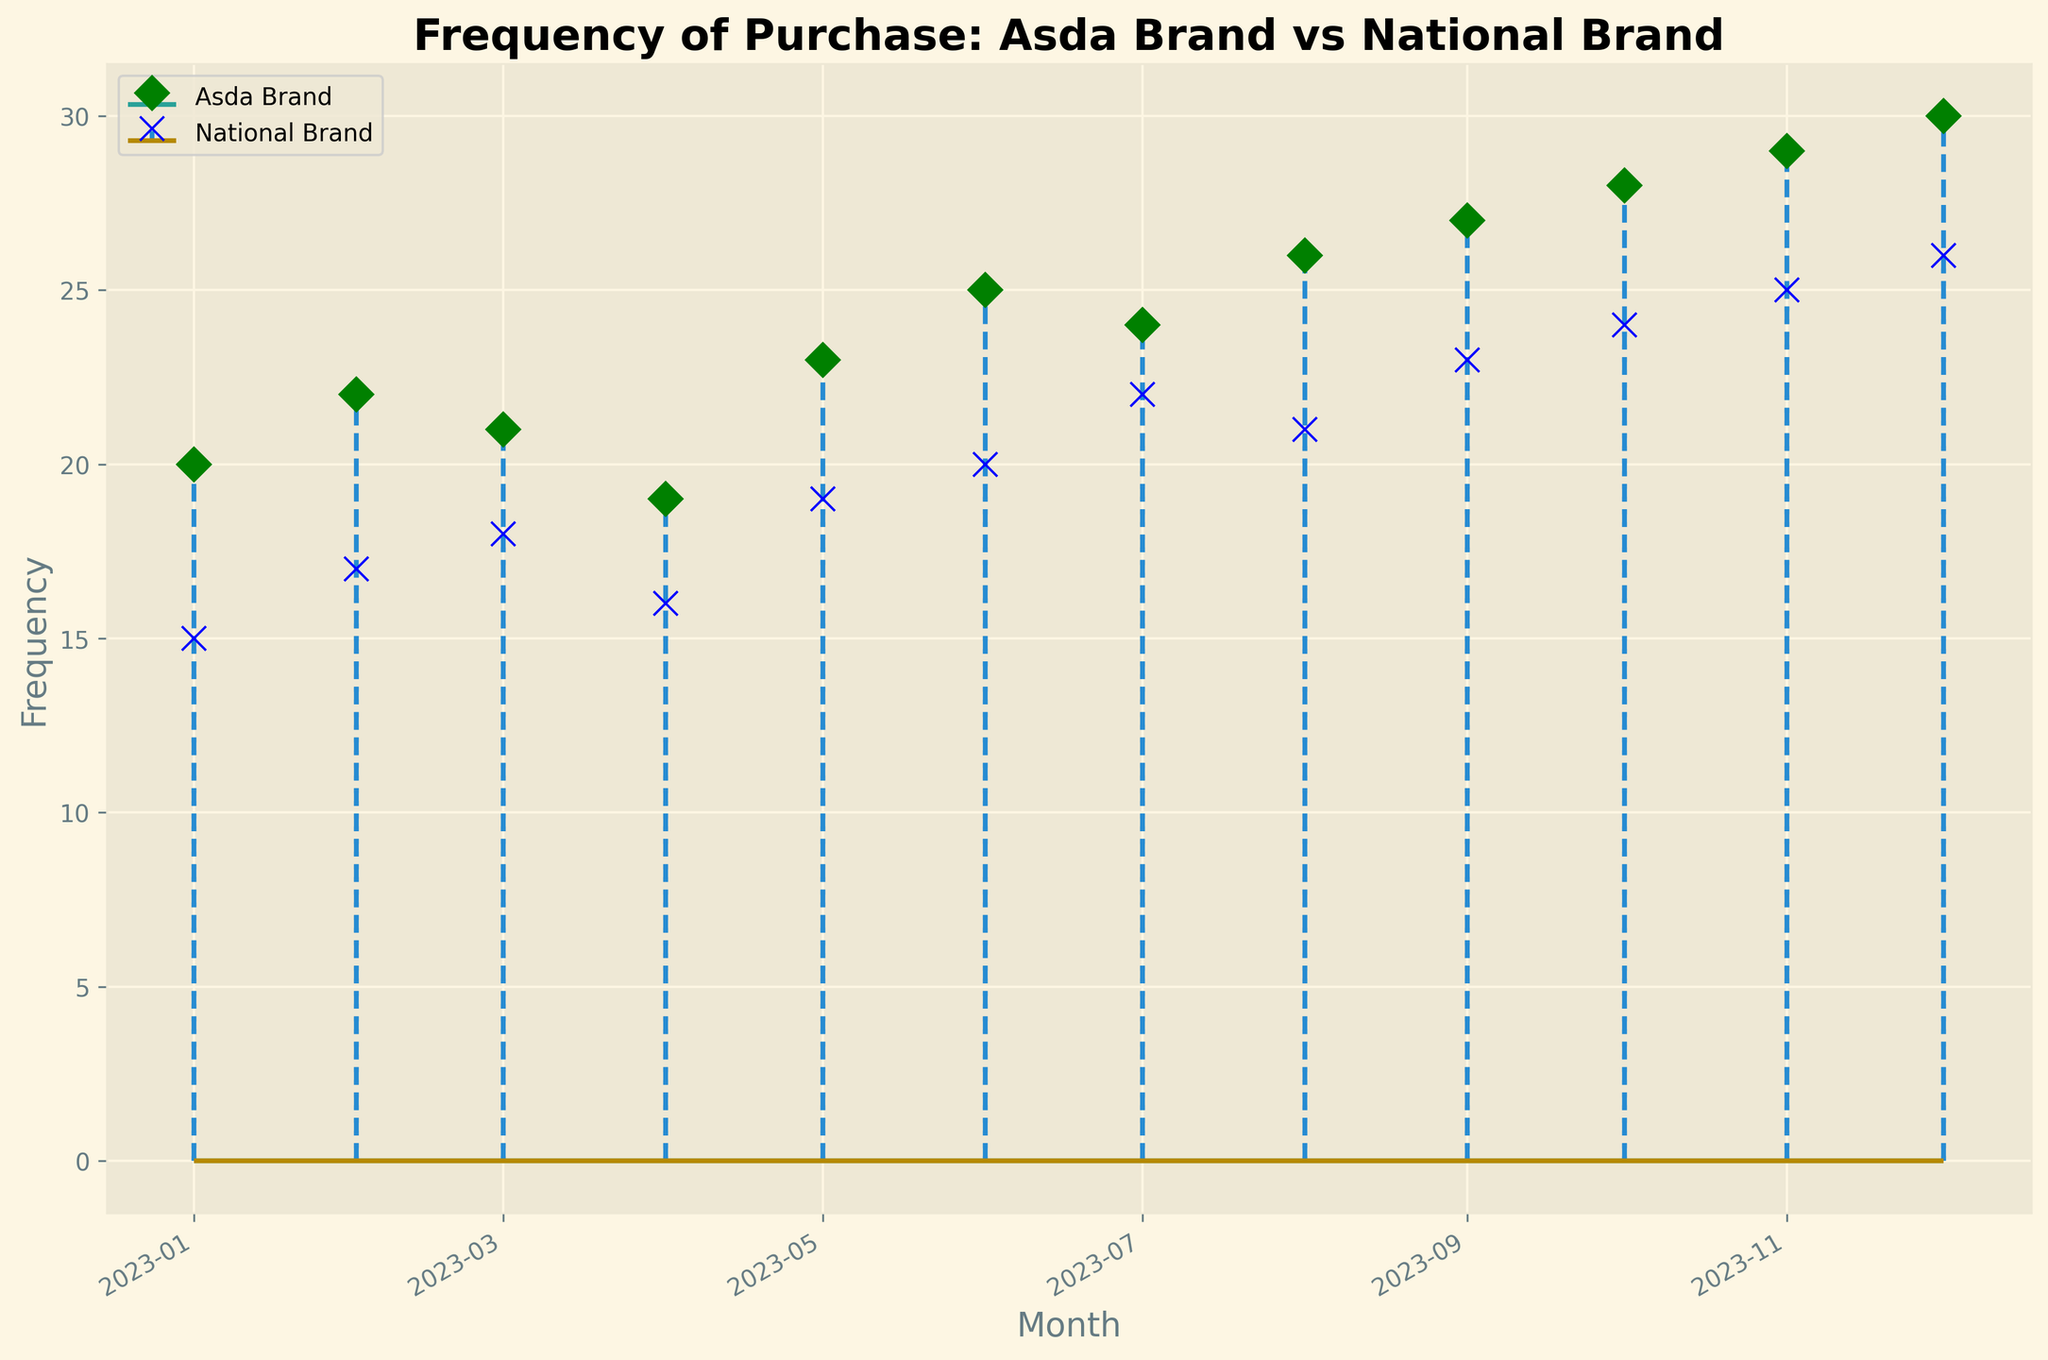When did the Asda brand have the highest frequency of purchases? By looking at the stem for the Asda brand, we can see the highest point is at the end of the plot, corresponding to December 2023.
Answer: December 2023 How does the frequency of purchases for national brands compare to Asda brands in January 2023? In January, the stem plot shows Asda brand has a frequency of 20, while the national brand has a frequency of 15. Thus, the Asda brand frequency is higher.
Answer: Asda brand is higher What's the difference in purchase frequency between Asda and national brands in June 2023? In June, the frequency for Asda is 25 and for national brands is 20. Subtracting these values gives the difference: 25 - 20 = 5.
Answer: 5 Which brand had a more consistent frequency over the year? By examining the trendlines, the national brand's frequency increases more gradually compared to the fluctuating pattern of the Asda brand. Thus, the national brand is more consistent.
Answer: National brand What is the average frequency of purchase for Asda brand across all months? The sum of frequencies for Asda brand over 12 months is 20+22+21+19+23+25+24+26+27+28+29+30 = 294. Dividing by 12 months gives the average: 294 / 12 = 24.5.
Answer: 24.5 Between which months did the frequency of Asda brand purchases see the largest increase? By observing the stems, the largest increase is from November to December, where the frequency jumps from 29 to 30.
Answer: November to December What month shows the smallest difference in purchase frequency between Asda and national brands? By checking month-by-month differences, March shows the smallest difference with Asda at 21 and national at 18, giving a difference of 3.
Answer: March During which month is the frequency of national brand purchases equal to 19? Referring to the plot, May shows a national brand frequency of 19.
Answer: May If you sum the frequencies of both brands in August, what is the total? In August, Asda brand has a frequency of 26 and the national brand has 21. Summing these gives 26 + 21 = 47.
Answer: 47 